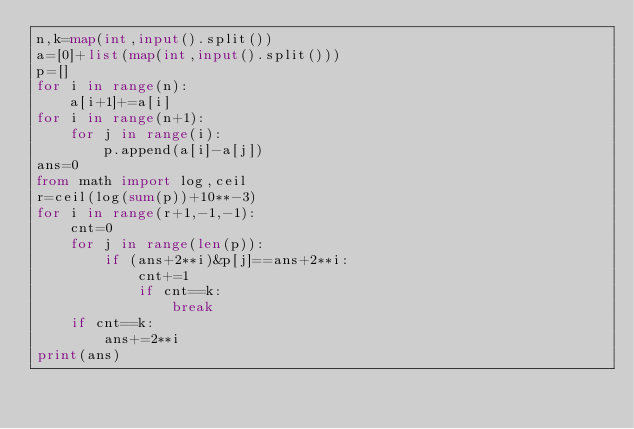Convert code to text. <code><loc_0><loc_0><loc_500><loc_500><_Python_>n,k=map(int,input().split())
a=[0]+list(map(int,input().split()))
p=[]
for i in range(n):
	a[i+1]+=a[i]
for i in range(n+1):
	for j in range(i):
		p.append(a[i]-a[j])
ans=0
from math import log,ceil
r=ceil(log(sum(p))+10**-3)
for i in range(r+1,-1,-1):
	cnt=0
	for j in range(len(p)):
		if (ans+2**i)&p[j]==ans+2**i:
			cnt+=1
			if cnt==k:
				break
	if cnt==k:
		ans+=2**i
print(ans)</code> 